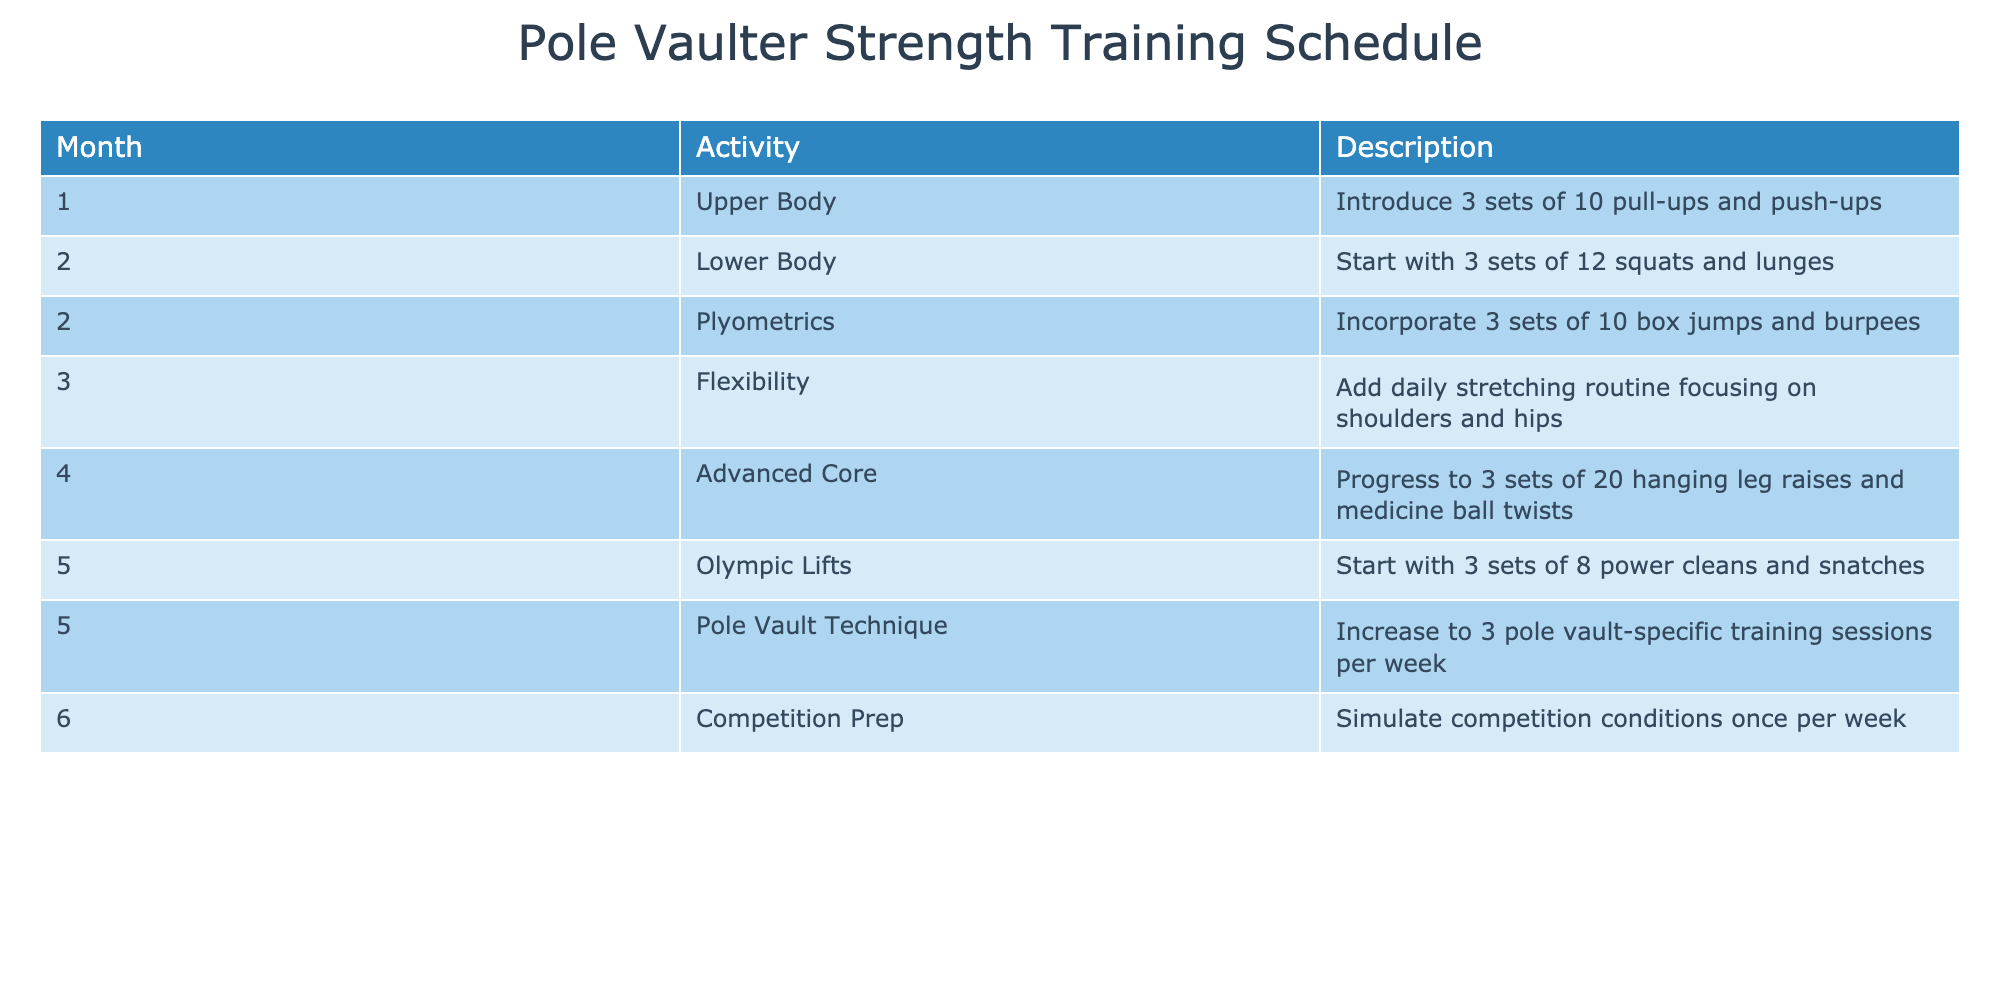What activities are scheduled for month 5? By looking at the table and finding the row for month 5, I see that it includes two activities: "Olympic Lifts" and "Pole Vault Technique".
Answer: Olympic Lifts and Pole Vault Technique How many sets of squats are included in month 2? The table indicates that in month 2, "Lower Body" training includes "3 sets of 12 squats".
Answer: 3 sets Is there a flexibility training included in the schedule? According to the table, month 3 features an activity labeled "Flexibility", indicating that there is indeed flexibility training included.
Answer: Yes Which activity requires more than 20 repetitions? Looking at the activities in the table, the "Advanced Core" activity in month 4 specifies "3 sets of 20 hanging leg raises", which is more than 20 repetitions.
Answer: Advanced Core What is the total number of pole vault-specific training sessions per week in month 5? In month 5, the "Pole Vault Technique" activity states that the schedule increases to "3 pole vault-specific training sessions per week".
Answer: 3 sessions In which month is the daily stretching routine introduced? The table shows that the daily stretching routine is incorporated in month 3 under the "Flexibility" activity.
Answer: Month 3 What type of exercise is added in month 6, and how frequently is it performed? In month 6, the table indicates "Competition Prep", which includes simulating competition conditions once per week. Therefore, the exercise is performed weekly.
Answer: Competition Prep, once per week Are there any lower body exercises planned in month 1? Checking the table, month 1 has the "Upper Body" activity but does not mention any lower body exercises.
Answer: No Which month involves introducing Olympic Lifts? The table details that Olympic Lifts are introduced in month 5, as listed under the corresponding activity.
Answer: Month 5 